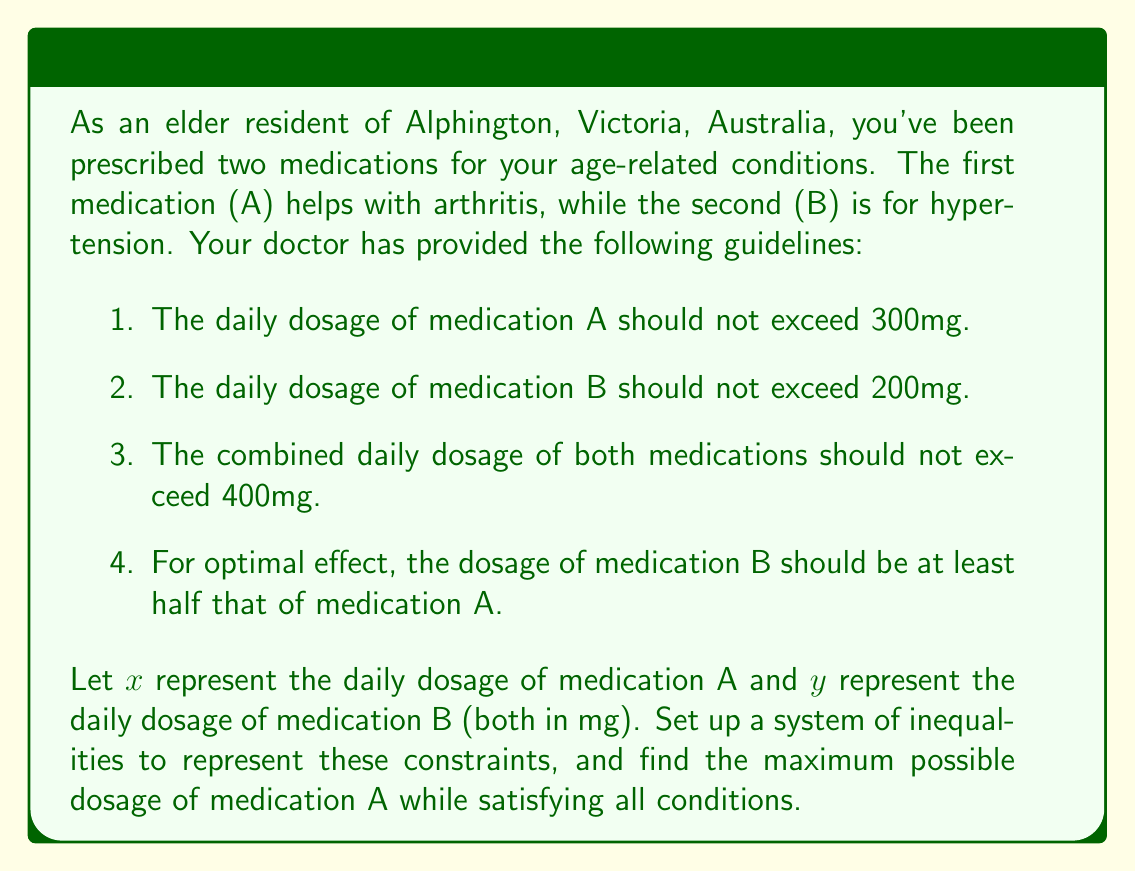What is the answer to this math problem? Let's approach this problem step by step:

1. First, we need to set up the system of inequalities based on the given constraints:

   a. $x \leq 300$ (Medication A dosage limit)
   b. $y \leq 200$ (Medication B dosage limit)
   c. $x + y \leq 400$ (Combined dosage limit)
   d. $y \geq \frac{1}{2}x$ (Medication B should be at least half of A)

2. We also know that both $x$ and $y$ must be non-negative:

   e. $x \geq 0$
   f. $y \geq 0$

3. To maximize the dosage of medication A, we need to find the largest possible value of $x$ that satisfies all these inequalities.

4. From inequalities (a) and (c), we can see that $x$ is bounded above by both 300 and $400 - y$.

5. From inequality (d), we know that $y \geq \frac{1}{2}x$. Substituting this into inequality (c):

   $x + \frac{1}{2}x \leq 400$
   $\frac{3}{2}x \leq 400$
   $x \leq \frac{800}{3} \approx 266.67$

6. Therefore, the maximum value of $x$ is the smallest of 300, 400 - y, and $\frac{800}{3}$.

7. The smallest of these upper bounds is $\frac{800}{3}$.

8. To verify, let's check if this satisfies all conditions:

   $x = \frac{800}{3} \approx 266.67$
   $y = \frac{1}{2}x = \frac{400}{3} \approx 133.33$

   This satisfies all inequalities:
   - $\frac{800}{3} < 300$
   - $\frac{400}{3} < 200$
   - $\frac{800}{3} + \frac{400}{3} = 400$
   - $\frac{400}{3} = \frac{1}{2}(\frac{800}{3})$
Answer: The maximum possible dosage of medication A is $\frac{800}{3} \approx 266.67$ mg. 